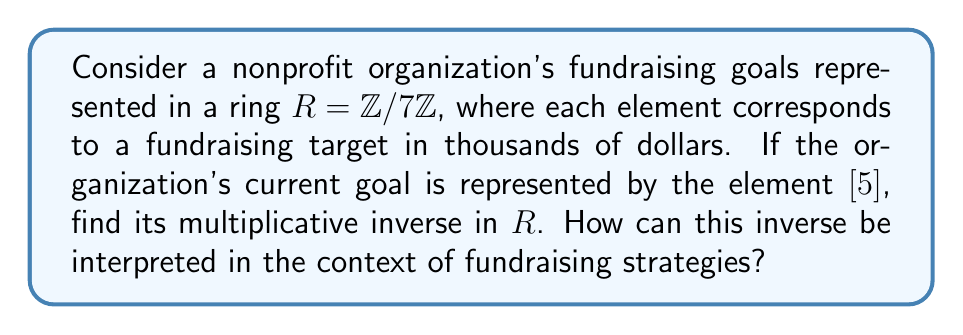Could you help me with this problem? 1) In the ring $R = \mathbb{Z}/7\mathbb{Z}$, we need to find an element $[x]$ such that $[5][x] = [1]$.

2) This is equivalent to solving the congruence equation:
   $5x \equiv 1 \pmod{7}$

3) We can solve this using the extended Euclidean algorithm:
   $7 = 1 \cdot 5 + 2$
   $5 = 2 \cdot 2 + 1$
   $2 = 2 \cdot 1 + 0$

4) Working backwards:
   $1 = 5 - 2 \cdot 2$
   $1 = 5 - 2(7 - 1 \cdot 5) = 3 \cdot 5 - 2 \cdot 7$

5) Therefore, $3 \cdot 5 \equiv 1 \pmod{7}$

6) This means $[3]$ is the multiplicative inverse of $[5]$ in $R$.

7) In the context of fundraising strategies, this can be interpreted as follows:
   If the current goal ($[5]$ thousand) is multiplied by 3, it would be equivalent to reaching the baseline goal ($[1]$ thousand) in terms of the overall fundraising cycle. This suggests that tripling the current efforts or resources could lead to achieving a significant milestone in the fundraising campaign.
Answer: $[3]$ 